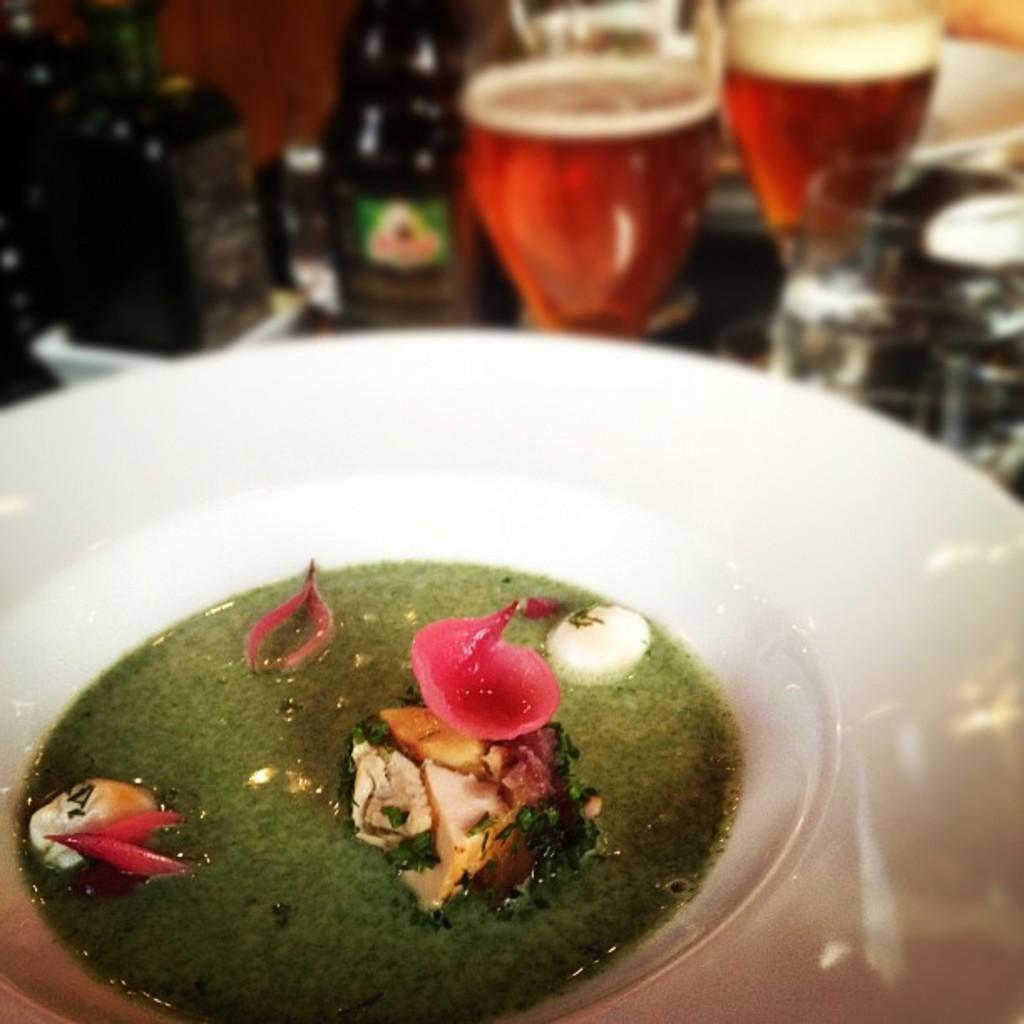Can you describe this image briefly? In this image, we can see a white color container and we can see some glasses. 